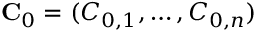Convert formula to latex. <formula><loc_0><loc_0><loc_500><loc_500>C _ { 0 } = ( C _ { 0 , 1 } , \hdots , C _ { 0 , n } )</formula> 